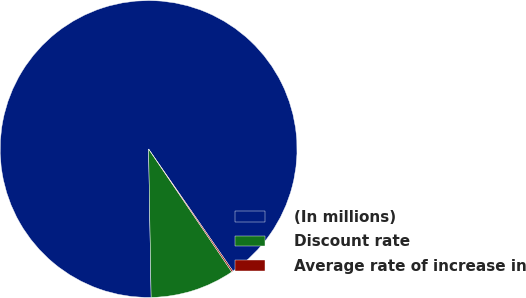Convert chart. <chart><loc_0><loc_0><loc_500><loc_500><pie_chart><fcel>(In millions)<fcel>Discount rate<fcel>Average rate of increase in<nl><fcel>90.66%<fcel>9.2%<fcel>0.15%<nl></chart> 